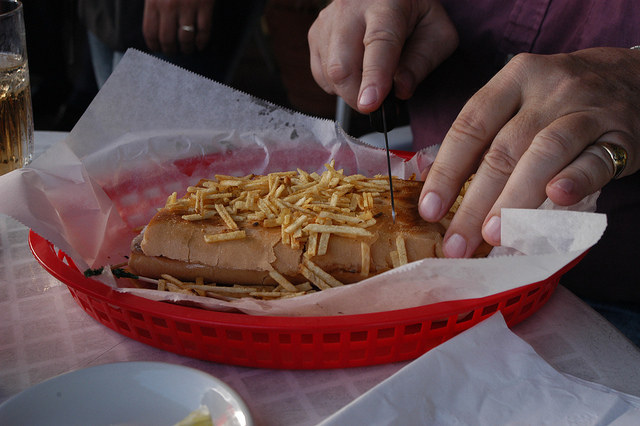<image>Is the white container biodegradable? It is unclear if the white container is biodegradable. The majority suggest it is not, but there are conflicting opinions. Is the white container biodegradable? I don't know if the white container is biodegradable. It can be both biodegradable and non-biodegradable. 